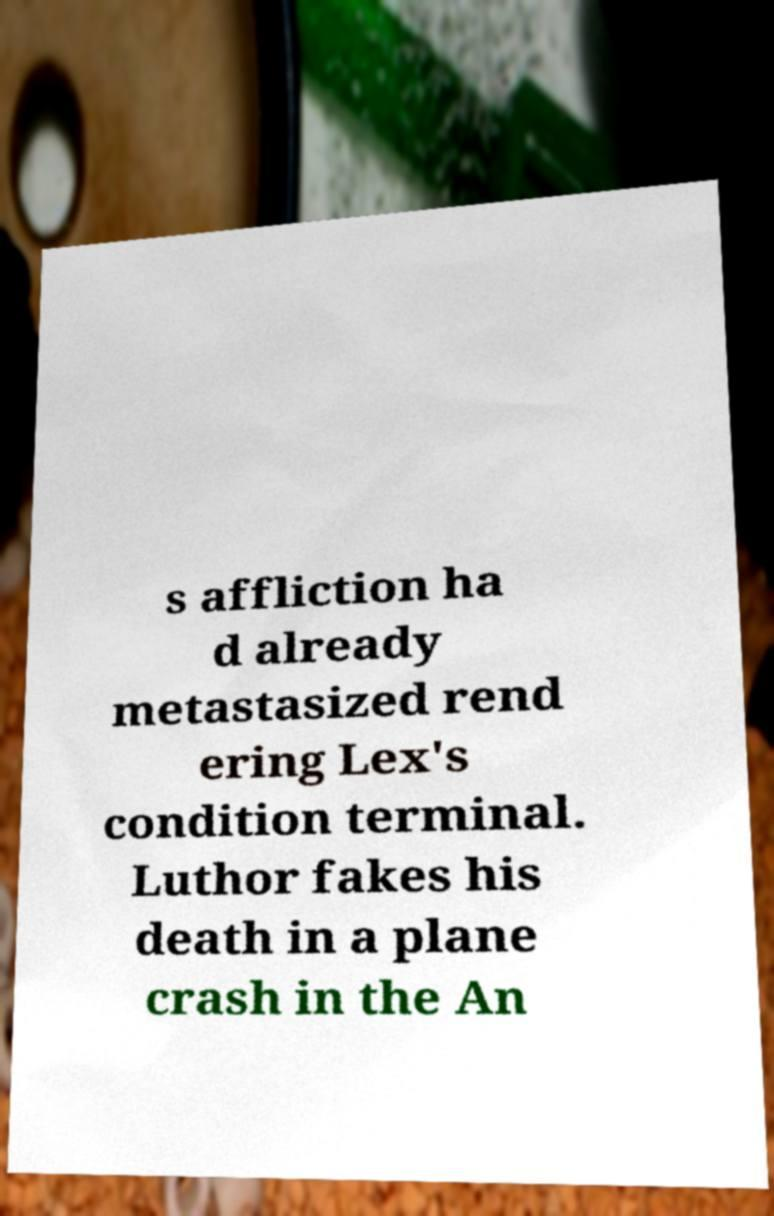Please read and relay the text visible in this image. What does it say? s affliction ha d already metastasized rend ering Lex's condition terminal. Luthor fakes his death in a plane crash in the An 